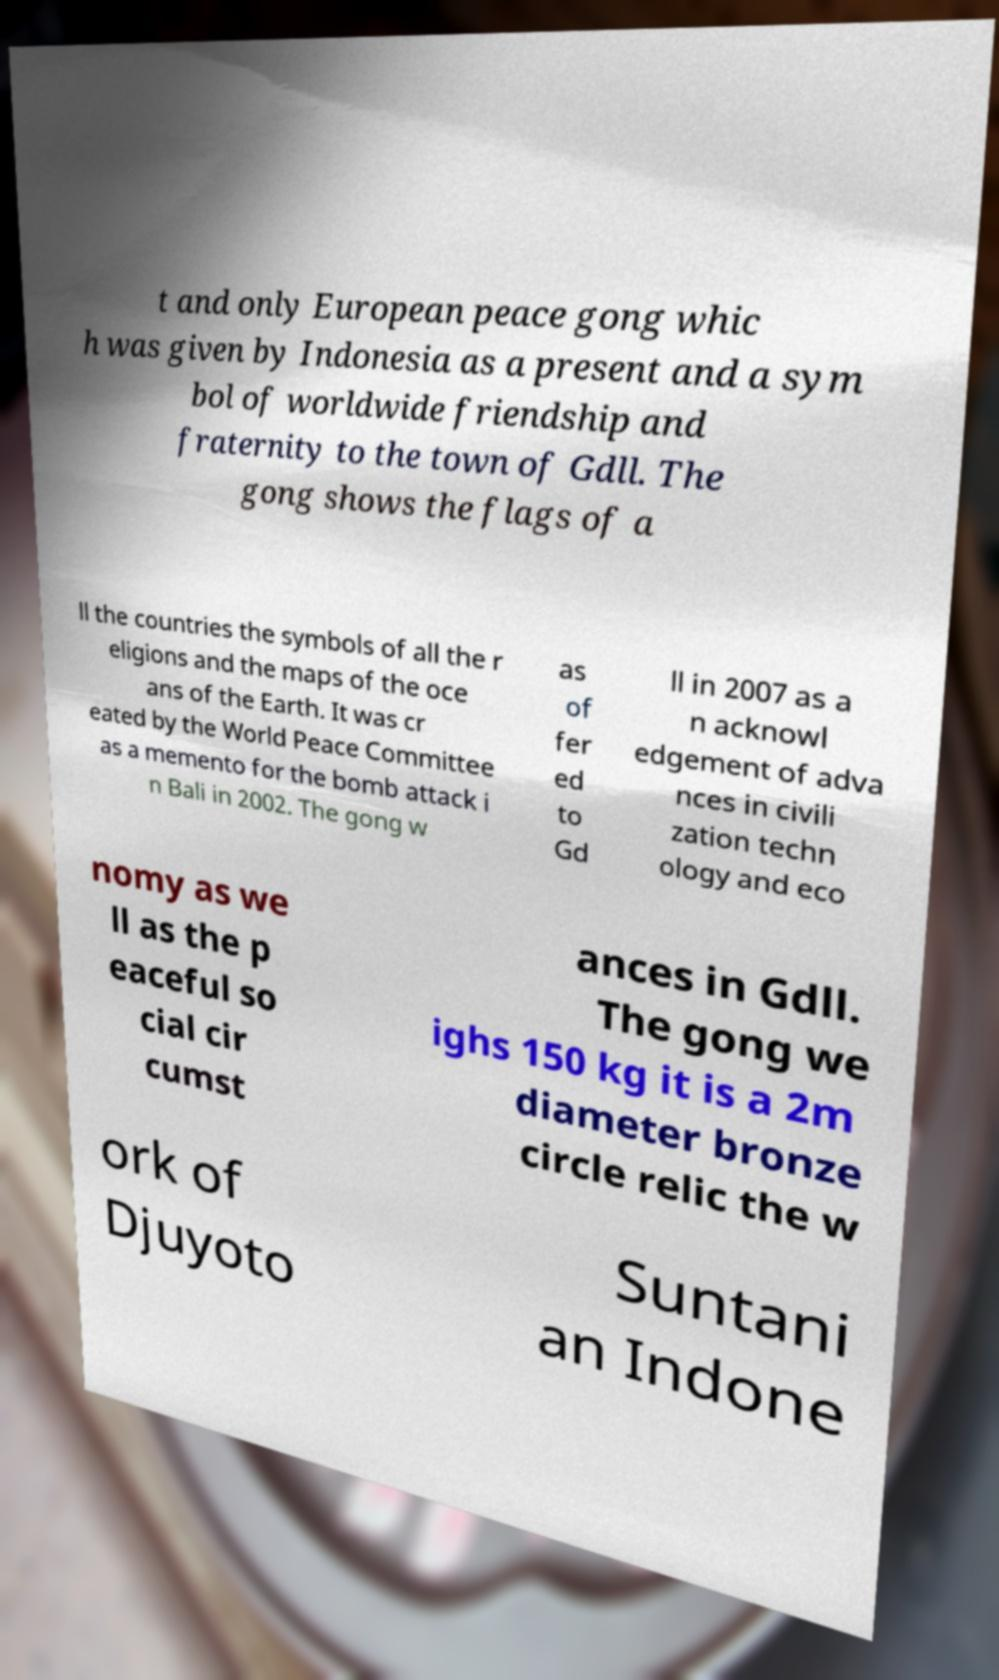There's text embedded in this image that I need extracted. Can you transcribe it verbatim? t and only European peace gong whic h was given by Indonesia as a present and a sym bol of worldwide friendship and fraternity to the town of Gdll. The gong shows the flags of a ll the countries the symbols of all the r eligions and the maps of the oce ans of the Earth. It was cr eated by the World Peace Committee as a memento for the bomb attack i n Bali in 2002. The gong w as of fer ed to Gd ll in 2007 as a n acknowl edgement of adva nces in civili zation techn ology and eco nomy as we ll as the p eaceful so cial cir cumst ances in Gdll. The gong we ighs 150 kg it is a 2m diameter bronze circle relic the w ork of Djuyoto Suntani an Indone 